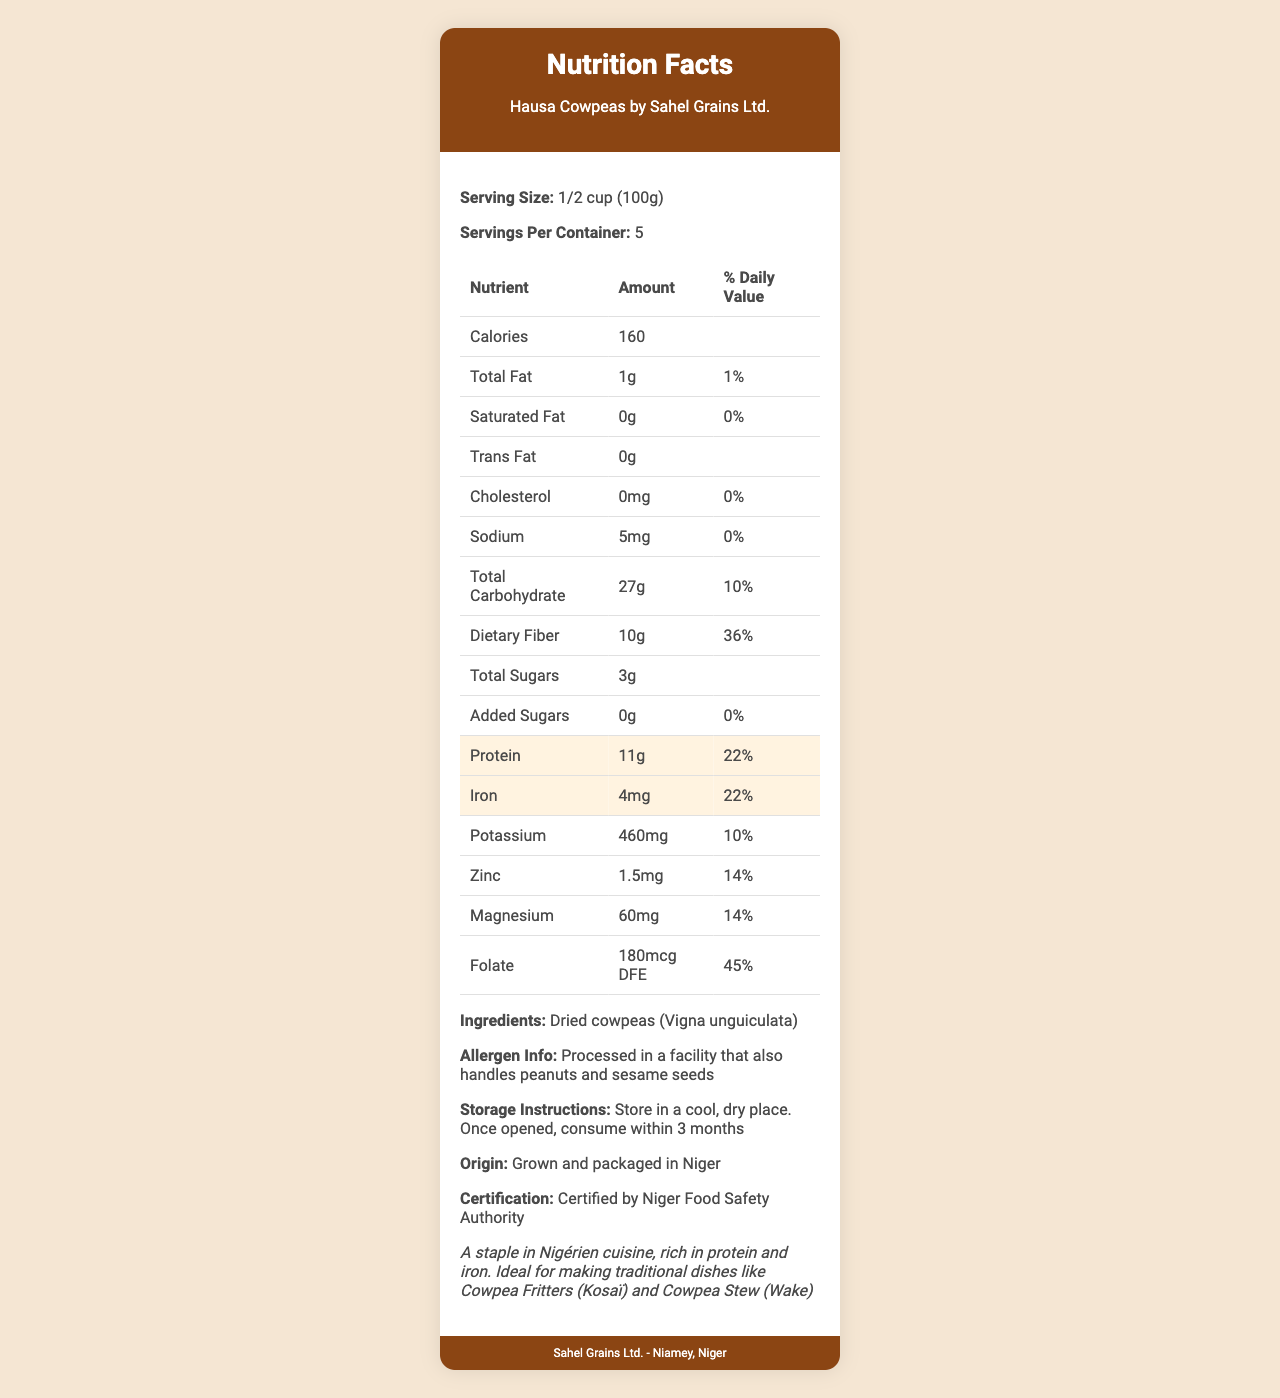what is the serving size for Hausa Cowpeas? The document specifies the serving size as "1/2 cup (100g)".
Answer: 1/2 cup (100g) how many servings are in each container? The document lists "Servings Per Container" as 5.
Answer: 5 what is the protein content per serving? Under the highlighted section, it is mentioned that the protein content is 11g per serving.
Answer: 11g what percentage of the daily iron value does one serving provide? The document states that one serving provides 22% of the Daily Value for iron.
Answer: 22% how many grams of dietary fiber are present in one serving? According to the document, each serving contains 10g of dietary fiber.
Answer: 10g which nutrient has the highest daily value percentage? A. Protein B. Iron C. Folate D. Dietary Fiber Folate has the highest daily value percentage at 45%.
Answer: C how much calcium is present per serving? A. 40mg B. 50mg C. 60mg D. 70mg The document states that there are 40mg of calcium per serving.
Answer: A is there any trans fat in Hausa Cowpeas? The document lists the trans fat content as 0g.
Answer: No describe the main idea of the document. The document is a Nutrition Facts label focusing on the nutritional content of Hausa Cowpeas, including detailed information on protein, iron, and other nutrients, along with serving size, allergen, storage, certification, and additional usage information.
Answer: It's a Nutrition Facts label for Hausa Cowpeas by Sahel Grains Ltd., highlighting the product's nutritional content, especially its protein and iron, and providing additional information such as serving size, allergen info, storage instructions, and certification. does the document provide the carbohydrate content? The document lists the total carbohydrate content as 27g per serving.
Answer: Yes where are these cowpeas grown and packaged? The "Origin" section specifies that the cowpeas are grown and packaged in Niger.
Answer: Niger what is the cooking method suggested in the additional info section? The additional info section suggests using the cowpeas for traditional dishes like Cowpea Fritters (Kosaï) and Cowpea Stew (Wake).
Answer: Ideal for making traditional dishes like Cowpea Fritters (Kosaï) and Cowpea Stew (Wake) who certified the Hausa Cowpeas? The document mentions that the product is certified by the Niger Food Safety Authority.
Answer: Niger Food Safety Authority what is the storage instruction? The document instructs to store the cowpeas in a cool, dry place and to consume within 3 months once opened.
Answer: Store in a cool, dry place. Once opened, consume within 3 months do Hausa Cowpeas contain any added sugars? The document specifies the added sugars content as 0g.
Answer: No is this product suitable for someone with peanut allergies? Although the product itself does not contain peanuts, it is processed in a facility that handles peanuts, which may be a concern for someone with a severe peanut allergy.
Answer: Cannot be determined 